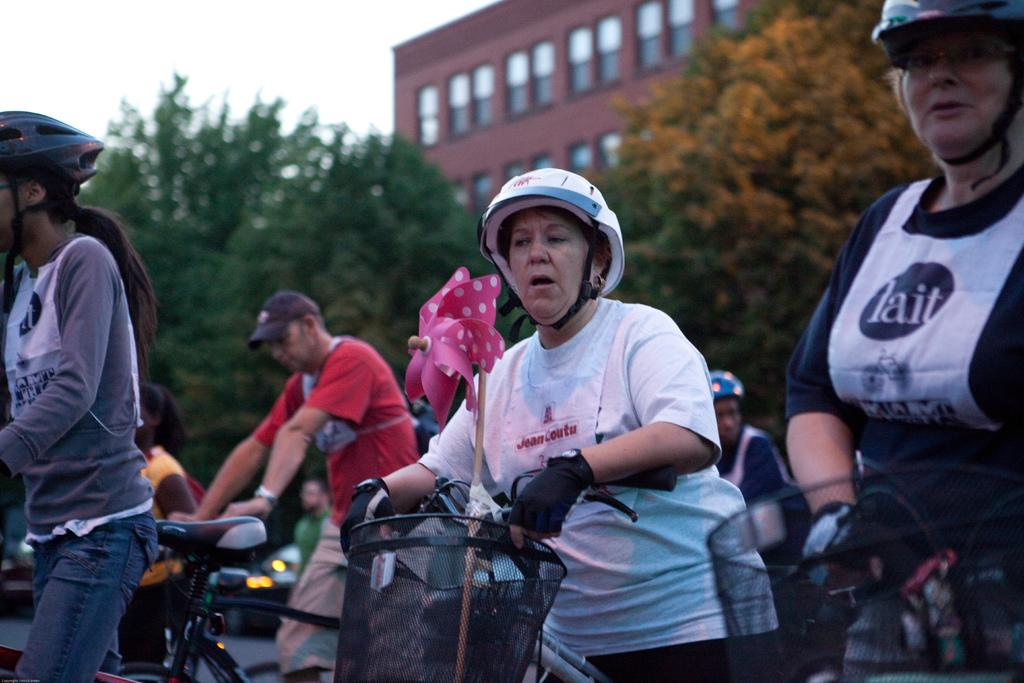What are the people in the image doing? The people in the image are sitting on a bicycle. What can be seen in the background of the image? There are trees and a building in the image. What is the manager's reaction to the crowd in the image? There is no manager or crowd present in the image. 